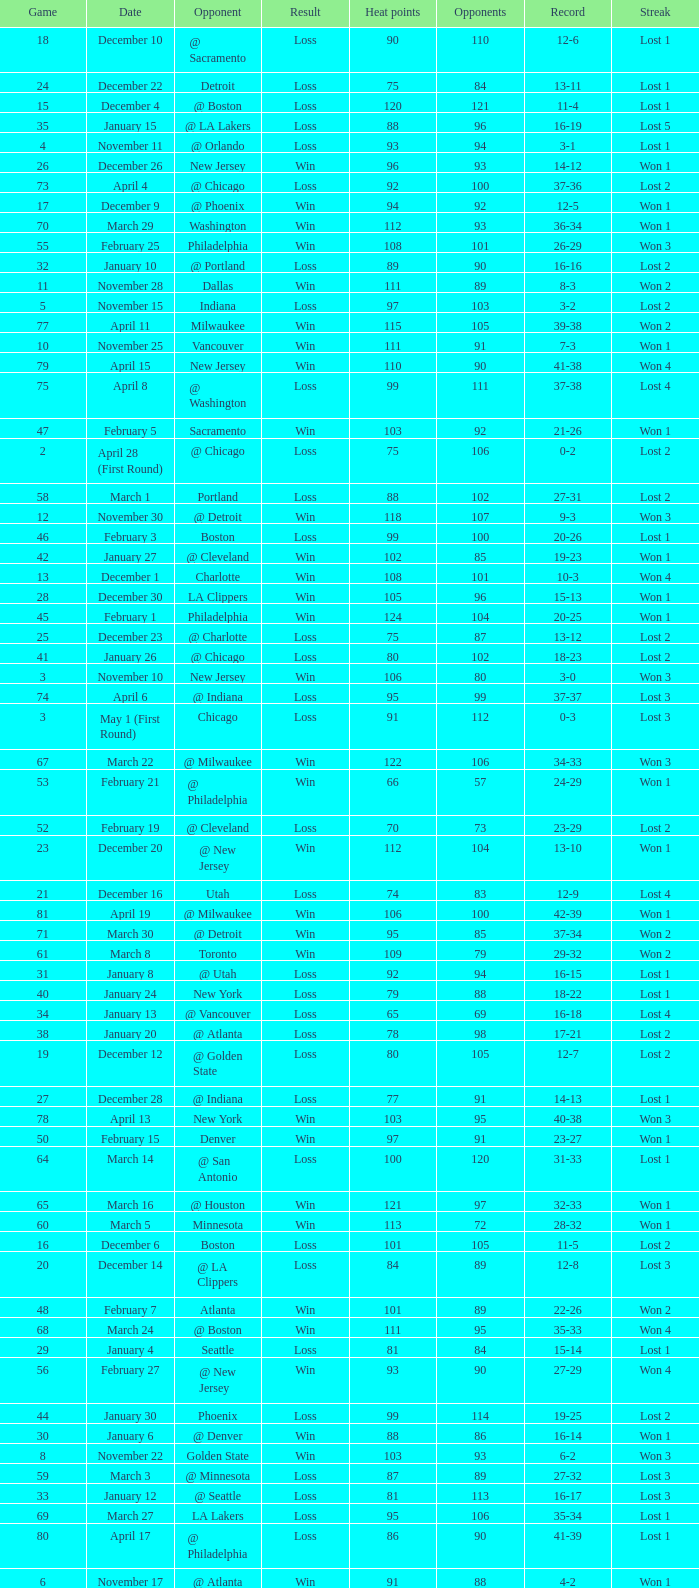What is Streak, when Heat Points is "101", and when Game is "16"? Lost 2. Could you parse the entire table? {'header': ['Game', 'Date', 'Opponent', 'Result', 'Heat points', 'Opponents', 'Record', 'Streak'], 'rows': [['18', 'December 10', '@ Sacramento', 'Loss', '90', '110', '12-6', 'Lost 1'], ['24', 'December 22', 'Detroit', 'Loss', '75', '84', '13-11', 'Lost 1'], ['15', 'December 4', '@ Boston', 'Loss', '120', '121', '11-4', 'Lost 1'], ['35', 'January 15', '@ LA Lakers', 'Loss', '88', '96', '16-19', 'Lost 5'], ['4', 'November 11', '@ Orlando', 'Loss', '93', '94', '3-1', 'Lost 1'], ['26', 'December 26', 'New Jersey', 'Win', '96', '93', '14-12', 'Won 1'], ['73', 'April 4', '@ Chicago', 'Loss', '92', '100', '37-36', 'Lost 2'], ['17', 'December 9', '@ Phoenix', 'Win', '94', '92', '12-5', 'Won 1'], ['70', 'March 29', 'Washington', 'Win', '112', '93', '36-34', 'Won 1'], ['55', 'February 25', 'Philadelphia', 'Win', '108', '101', '26-29', 'Won 3'], ['32', 'January 10', '@ Portland', 'Loss', '89', '90', '16-16', 'Lost 2'], ['11', 'November 28', 'Dallas', 'Win', '111', '89', '8-3', 'Won 2'], ['5', 'November 15', 'Indiana', 'Loss', '97', '103', '3-2', 'Lost 2'], ['77', 'April 11', 'Milwaukee', 'Win', '115', '105', '39-38', 'Won 2'], ['10', 'November 25', 'Vancouver', 'Win', '111', '91', '7-3', 'Won 1'], ['79', 'April 15', 'New Jersey', 'Win', '110', '90', '41-38', 'Won 4'], ['75', 'April 8', '@ Washington', 'Loss', '99', '111', '37-38', 'Lost 4'], ['47', 'February 5', 'Sacramento', 'Win', '103', '92', '21-26', 'Won 1'], ['2', 'April 28 (First Round)', '@ Chicago', 'Loss', '75', '106', '0-2', 'Lost 2'], ['58', 'March 1', 'Portland', 'Loss', '88', '102', '27-31', 'Lost 2'], ['12', 'November 30', '@ Detroit', 'Win', '118', '107', '9-3', 'Won 3'], ['46', 'February 3', 'Boston', 'Loss', '99', '100', '20-26', 'Lost 1'], ['42', 'January 27', '@ Cleveland', 'Win', '102', '85', '19-23', 'Won 1'], ['13', 'December 1', 'Charlotte', 'Win', '108', '101', '10-3', 'Won 4'], ['28', 'December 30', 'LA Clippers', 'Win', '105', '96', '15-13', 'Won 1'], ['45', 'February 1', 'Philadelphia', 'Win', '124', '104', '20-25', 'Won 1'], ['25', 'December 23', '@ Charlotte', 'Loss', '75', '87', '13-12', 'Lost 2'], ['41', 'January 26', '@ Chicago', 'Loss', '80', '102', '18-23', 'Lost 2'], ['3', 'November 10', 'New Jersey', 'Win', '106', '80', '3-0', 'Won 3'], ['74', 'April 6', '@ Indiana', 'Loss', '95', '99', '37-37', 'Lost 3'], ['3', 'May 1 (First Round)', 'Chicago', 'Loss', '91', '112', '0-3', 'Lost 3'], ['67', 'March 22', '@ Milwaukee', 'Win', '122', '106', '34-33', 'Won 3'], ['53', 'February 21', '@ Philadelphia', 'Win', '66', '57', '24-29', 'Won 1'], ['52', 'February 19', '@ Cleveland', 'Loss', '70', '73', '23-29', 'Lost 2'], ['23', 'December 20', '@ New Jersey', 'Win', '112', '104', '13-10', 'Won 1'], ['21', 'December 16', 'Utah', 'Loss', '74', '83', '12-9', 'Lost 4'], ['81', 'April 19', '@ Milwaukee', 'Win', '106', '100', '42-39', 'Won 1'], ['71', 'March 30', '@ Detroit', 'Win', '95', '85', '37-34', 'Won 2'], ['61', 'March 8', 'Toronto', 'Win', '109', '79', '29-32', 'Won 2'], ['31', 'January 8', '@ Utah', 'Loss', '92', '94', '16-15', 'Lost 1'], ['40', 'January 24', 'New York', 'Loss', '79', '88', '18-22', 'Lost 1'], ['34', 'January 13', '@ Vancouver', 'Loss', '65', '69', '16-18', 'Lost 4'], ['38', 'January 20', '@ Atlanta', 'Loss', '78', '98', '17-21', 'Lost 2'], ['19', 'December 12', '@ Golden State', 'Loss', '80', '105', '12-7', 'Lost 2'], ['27', 'December 28', '@ Indiana', 'Loss', '77', '91', '14-13', 'Lost 1'], ['78', 'April 13', 'New York', 'Win', '103', '95', '40-38', 'Won 3'], ['50', 'February 15', 'Denver', 'Win', '97', '91', '23-27', 'Won 1'], ['64', 'March 14', '@ San Antonio', 'Loss', '100', '120', '31-33', 'Lost 1'], ['65', 'March 16', '@ Houston', 'Win', '121', '97', '32-33', 'Won 1'], ['60', 'March 5', 'Minnesota', 'Win', '113', '72', '28-32', 'Won 1'], ['16', 'December 6', 'Boston', 'Loss', '101', '105', '11-5', 'Lost 2'], ['20', 'December 14', '@ LA Clippers', 'Loss', '84', '89', '12-8', 'Lost 3'], ['48', 'February 7', 'Atlanta', 'Win', '101', '89', '22-26', 'Won 2'], ['68', 'March 24', '@ Boston', 'Win', '111', '95', '35-33', 'Won 4'], ['29', 'January 4', 'Seattle', 'Loss', '81', '84', '15-14', 'Lost 1'], ['56', 'February 27', '@ New Jersey', 'Win', '93', '90', '27-29', 'Won 4'], ['44', 'January 30', 'Phoenix', 'Loss', '99', '114', '19-25', 'Lost 2'], ['30', 'January 6', '@ Denver', 'Win', '88', '86', '16-14', 'Won 1'], ['8', 'November 22', 'Golden State', 'Win', '103', '93', '6-2', 'Won 3'], ['59', 'March 3', '@ Minnesota', 'Loss', '87', '89', '27-32', 'Lost 3'], ['33', 'January 12', '@ Seattle', 'Loss', '81', '113', '16-17', 'Lost 3'], ['69', 'March 27', 'LA Lakers', 'Loss', '95', '106', '35-34', 'Lost 1'], ['80', 'April 17', '@ Philadelphia', 'Loss', '86', '90', '41-39', 'Lost 1'], ['6', 'November 17', '@ Atlanta', 'Win', '91', '88', '4-2', 'Won 1'], ['76', 'April 10', '@ Charlotte', 'Win', '116', '95', '38-38', 'Won 1'], ['2', 'November 8', 'Houston', 'Win', '89', '82', '2-0', 'Won 2'], ['14', 'December 3', '@ Toronto', 'Win', '112', '94', '11-3', 'Won 5'], ['36', 'January 17', 'Washington', 'Win', '96', '89', '17-19', 'Won 1'], ['37', 'January 19', 'Charlotte', 'Loss', '106', '114', '17-20', 'Lost 1'], ['63', 'March 12', '@ Dallas', 'Win', '125', '118', '31-32', 'Won 4'], ['54', 'February 23', 'Chicago', 'Win', '113', '104', '25-29', 'Won 2'], ['43', 'January 29', '@ New York', 'Loss', '85', '94', '19-24', 'Lost 1'], ['62', 'March 10', 'Cleveland', 'Win', '88', '81', '30-32', 'Won 3'], ['9', 'November 24', '@ Washington', 'Loss', '94', '110', '6-3', 'Lost 1'], ['22', 'December 19', '@ New York', 'Loss', '70', '89', '12-10', 'Lost 5'], ['49', 'February 13', 'Toronto', 'Loss', '87', '98', '22-27', 'Lost 1'], ['51', 'February 17', 'Orlando', 'Loss', '93', '95', '23-28', 'Lost 1'], ['66', 'March 20', 'Detroit', 'Win', '102', '93', '33-33', 'Won 2'], ['1', 'November 4', 'Cleveland', 'Win', '85', '71', '1-0', 'Won 1'], ['1', 'April 26 (First Round)', '@ Chicago', 'Loss', '85', '102', '0-1', 'Lost 1'], ['57', 'February 28', '@ Orlando', 'Loss', '112', '116', '27-30', 'Lost 1'], ['72', 'April 2', 'Chicago', 'Loss', '92', '110', '37-35', 'Lost 1'], ['82', 'April 21', 'Atlanta', 'Loss', '92', '104', '42-40', 'Lost 1'], ['39', 'January 22', 'San Antonio', 'Win', '96', '89', '18-21', 'Won 1'], ['7', 'November 18', 'Orlando', 'Win', '93', '90', '5-2', 'Won 2']]} 